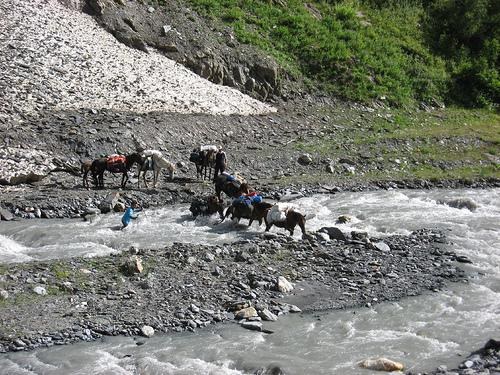Where are these animals located?

Choices:
A) mountains
B) beach
C) desert
D) arctic mountains 